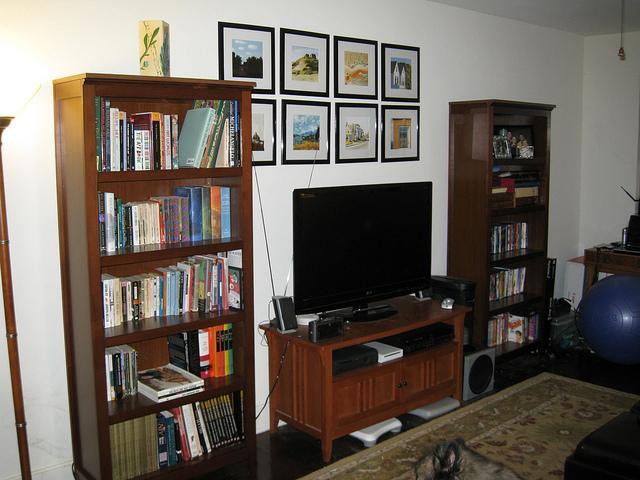What type of paint was used to paint the pictures hanging on the wall?

Choices:
A) acrylic
B) gouache
C) watercolor
D) oil watercolor 